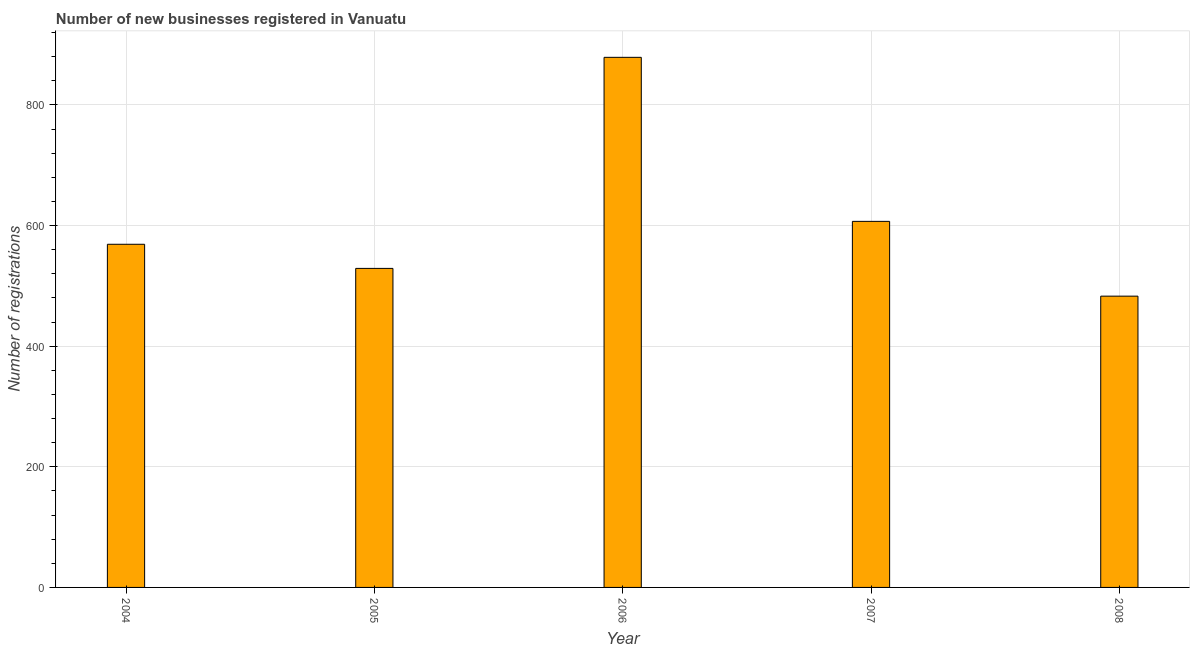Does the graph contain any zero values?
Ensure brevity in your answer.  No. What is the title of the graph?
Your response must be concise. Number of new businesses registered in Vanuatu. What is the label or title of the Y-axis?
Give a very brief answer. Number of registrations. What is the number of new business registrations in 2007?
Give a very brief answer. 607. Across all years, what is the maximum number of new business registrations?
Keep it short and to the point. 879. Across all years, what is the minimum number of new business registrations?
Offer a very short reply. 483. In which year was the number of new business registrations maximum?
Ensure brevity in your answer.  2006. What is the sum of the number of new business registrations?
Ensure brevity in your answer.  3067. What is the difference between the number of new business registrations in 2006 and 2007?
Keep it short and to the point. 272. What is the average number of new business registrations per year?
Provide a succinct answer. 613. What is the median number of new business registrations?
Ensure brevity in your answer.  569. What is the ratio of the number of new business registrations in 2004 to that in 2005?
Keep it short and to the point. 1.08. Is the number of new business registrations in 2005 less than that in 2006?
Provide a short and direct response. Yes. What is the difference between the highest and the second highest number of new business registrations?
Ensure brevity in your answer.  272. What is the difference between the highest and the lowest number of new business registrations?
Offer a terse response. 396. Are the values on the major ticks of Y-axis written in scientific E-notation?
Provide a succinct answer. No. What is the Number of registrations of 2004?
Offer a terse response. 569. What is the Number of registrations of 2005?
Your answer should be very brief. 529. What is the Number of registrations in 2006?
Your answer should be compact. 879. What is the Number of registrations in 2007?
Your answer should be very brief. 607. What is the Number of registrations in 2008?
Offer a very short reply. 483. What is the difference between the Number of registrations in 2004 and 2006?
Your response must be concise. -310. What is the difference between the Number of registrations in 2004 and 2007?
Keep it short and to the point. -38. What is the difference between the Number of registrations in 2005 and 2006?
Provide a succinct answer. -350. What is the difference between the Number of registrations in 2005 and 2007?
Keep it short and to the point. -78. What is the difference between the Number of registrations in 2005 and 2008?
Give a very brief answer. 46. What is the difference between the Number of registrations in 2006 and 2007?
Provide a short and direct response. 272. What is the difference between the Number of registrations in 2006 and 2008?
Your response must be concise. 396. What is the difference between the Number of registrations in 2007 and 2008?
Provide a short and direct response. 124. What is the ratio of the Number of registrations in 2004 to that in 2005?
Keep it short and to the point. 1.08. What is the ratio of the Number of registrations in 2004 to that in 2006?
Provide a short and direct response. 0.65. What is the ratio of the Number of registrations in 2004 to that in 2007?
Your response must be concise. 0.94. What is the ratio of the Number of registrations in 2004 to that in 2008?
Give a very brief answer. 1.18. What is the ratio of the Number of registrations in 2005 to that in 2006?
Provide a short and direct response. 0.6. What is the ratio of the Number of registrations in 2005 to that in 2007?
Your response must be concise. 0.87. What is the ratio of the Number of registrations in 2005 to that in 2008?
Give a very brief answer. 1.09. What is the ratio of the Number of registrations in 2006 to that in 2007?
Provide a succinct answer. 1.45. What is the ratio of the Number of registrations in 2006 to that in 2008?
Your answer should be very brief. 1.82. What is the ratio of the Number of registrations in 2007 to that in 2008?
Provide a short and direct response. 1.26. 